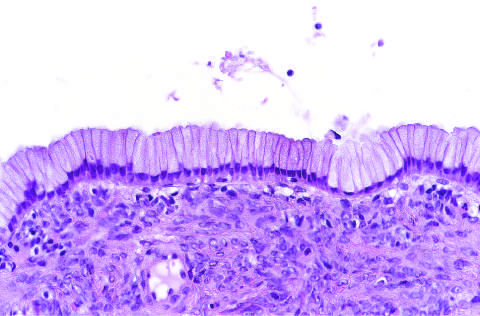what are the cysts lined by?
Answer the question using a single word or phrase. Columnar mucinous epithelium 